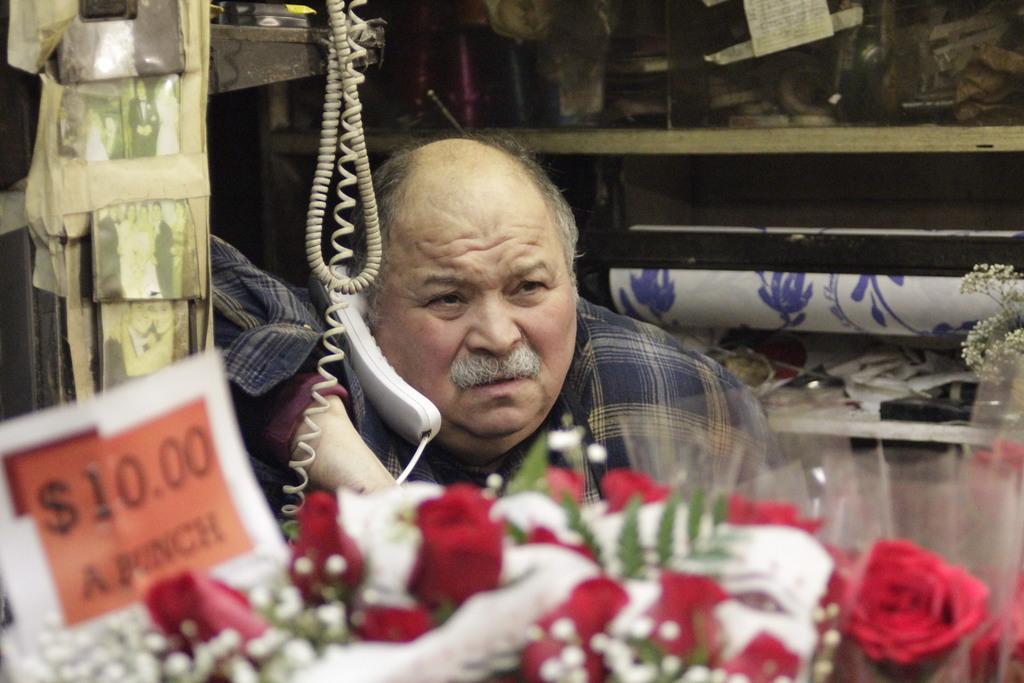How would you summarize this image in a sentence or two? This person kept a telephone receiver near his ear. In-front of this person there are wires, flowers and price tag. These are pictures. In that racks there are things. 